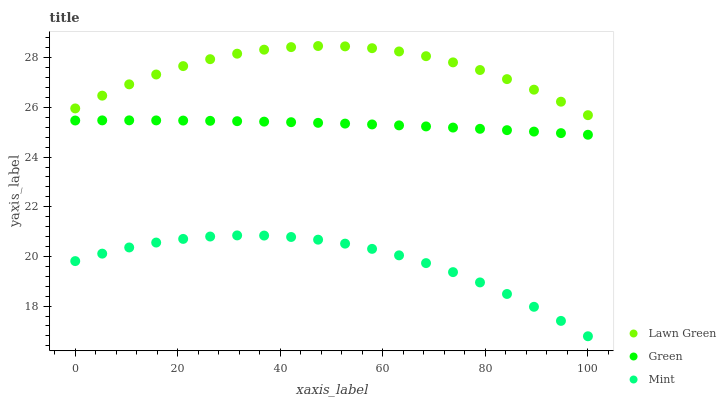Does Mint have the minimum area under the curve?
Answer yes or no. Yes. Does Lawn Green have the maximum area under the curve?
Answer yes or no. Yes. Does Green have the minimum area under the curve?
Answer yes or no. No. Does Green have the maximum area under the curve?
Answer yes or no. No. Is Green the smoothest?
Answer yes or no. Yes. Is Lawn Green the roughest?
Answer yes or no. Yes. Is Mint the smoothest?
Answer yes or no. No. Is Mint the roughest?
Answer yes or no. No. Does Mint have the lowest value?
Answer yes or no. Yes. Does Green have the lowest value?
Answer yes or no. No. Does Lawn Green have the highest value?
Answer yes or no. Yes. Does Green have the highest value?
Answer yes or no. No. Is Mint less than Green?
Answer yes or no. Yes. Is Lawn Green greater than Mint?
Answer yes or no. Yes. Does Mint intersect Green?
Answer yes or no. No. 